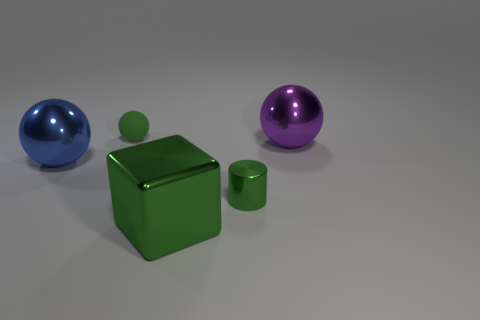Add 1 big green balls. How many objects exist? 6 Add 4 big blue metal objects. How many big blue metal objects are left? 5 Add 3 cylinders. How many cylinders exist? 4 Subtract 0 brown cubes. How many objects are left? 5 Subtract all cylinders. How many objects are left? 4 Subtract all small green blocks. Subtract all shiny blocks. How many objects are left? 4 